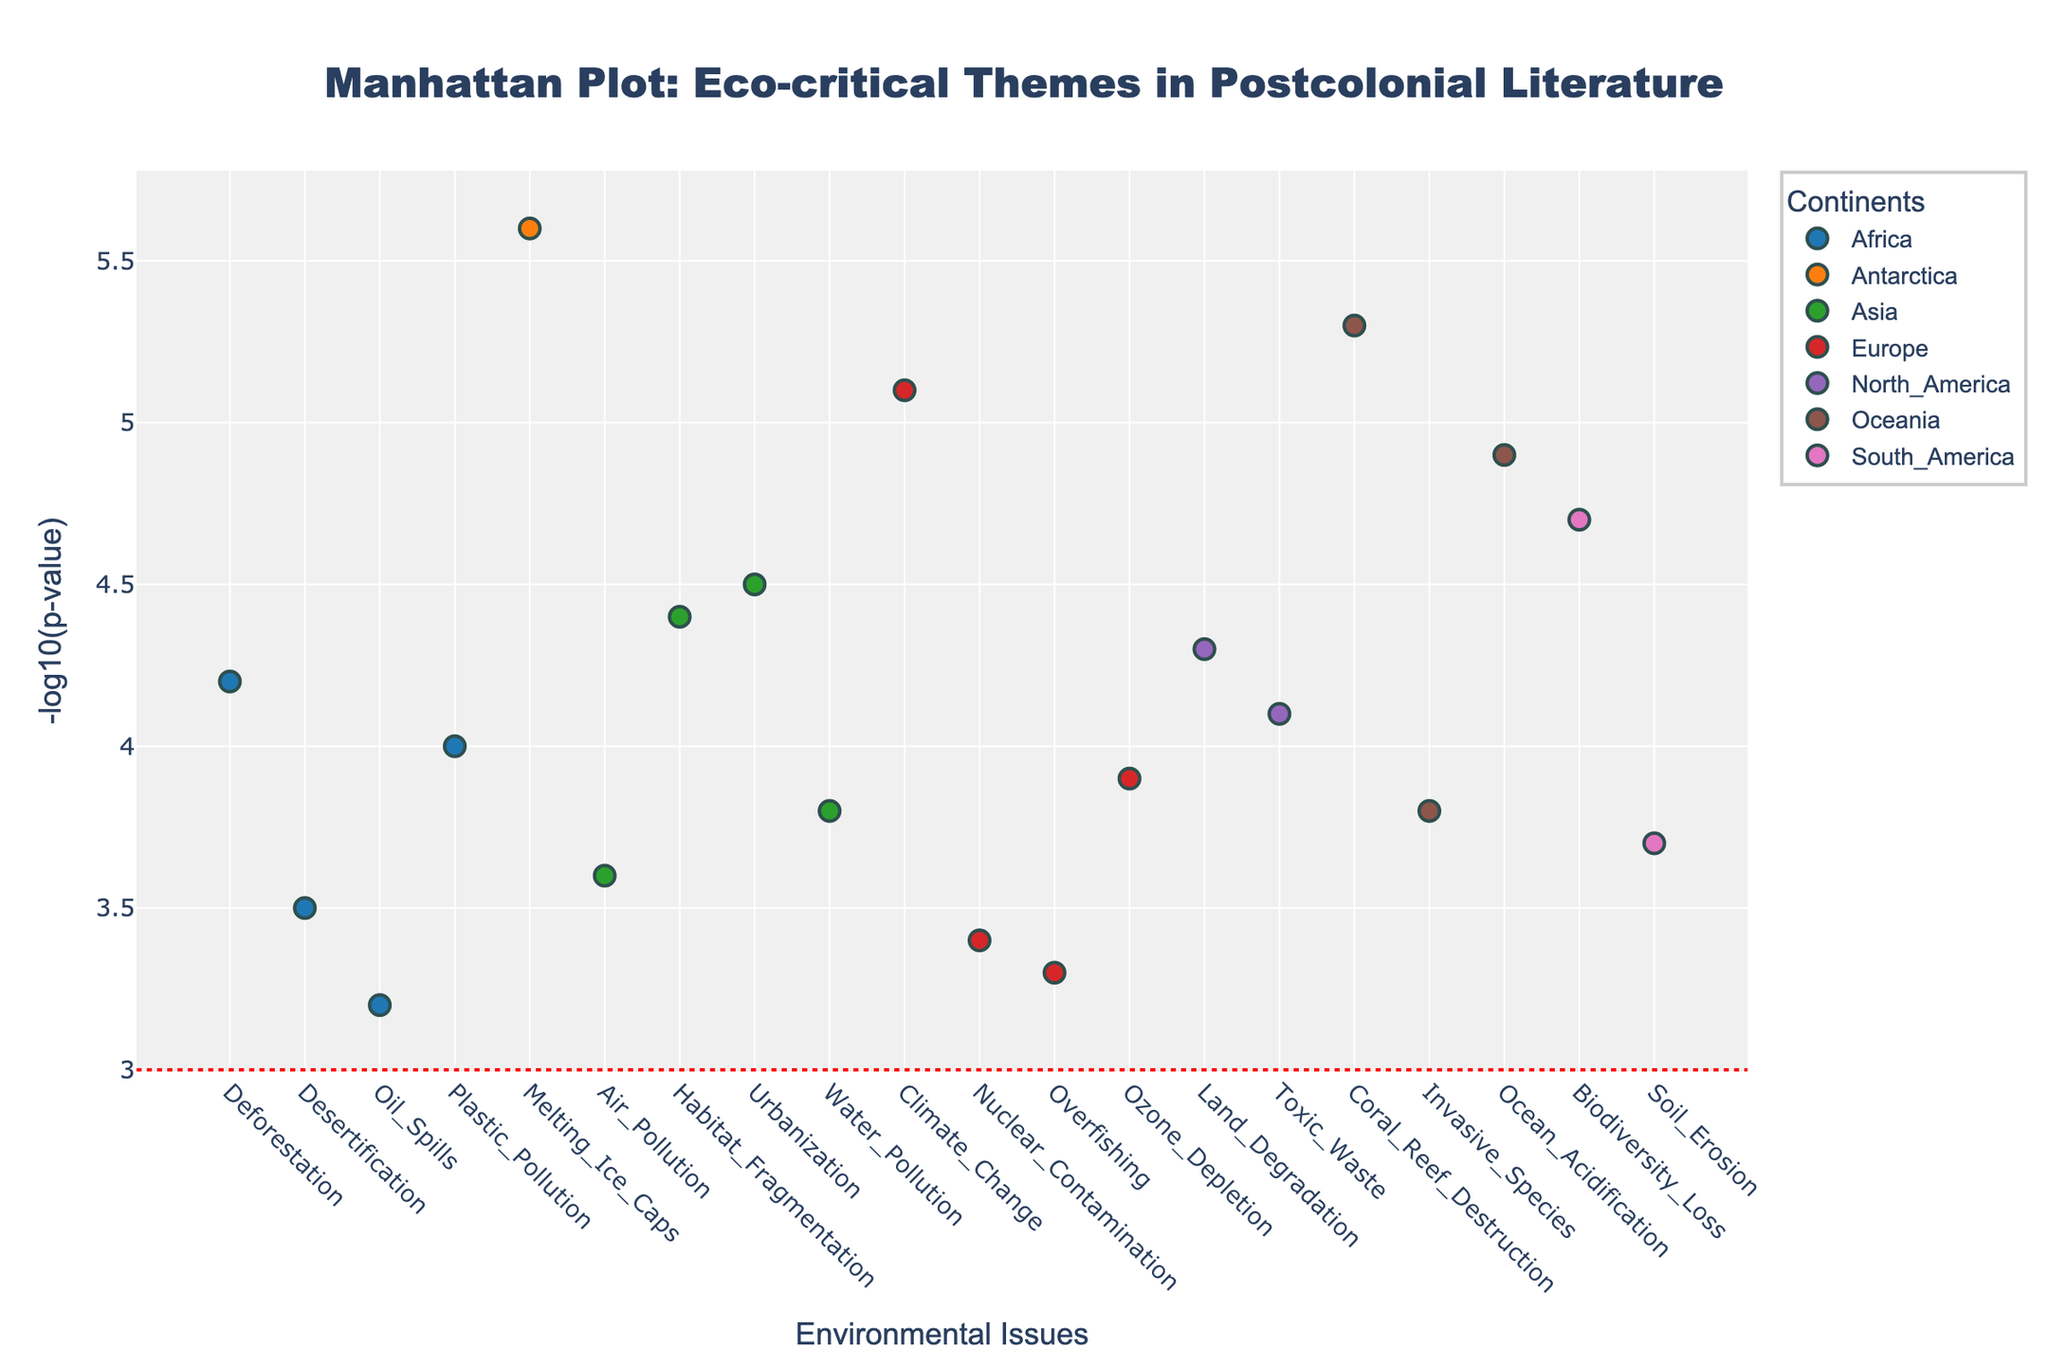What is the title of the plot? The title is located prominently at the top center of the plot. It reads, "Manhattan Plot: Eco-critical Themes in Postcolonial Literature".
Answer: Manhattan Plot: Eco-critical Themes in Postcolonial Literature Which continent has the environmental issue with the highest -log10(p-value)? By checking the y-axis values, the highest -log10(p-value) is 5.6 for the issue labeled "Melting_Ice_Caps" in "Antarctica".
Answer: Antarctica What does the horizontal red line at y=3 represent? A horizontal line drawn at y=3 signifies a threshold, often important in significance testing. A -log10(p-value) of 3 corresponds to a p-value of 0.001, indicating statistical significance.
Answer: A threshold of p-value = 0.001 How do Oceanic environmental issues compare in statistical significance? Oceanic issues plotted in Oceania can be evaluated by their y-axis values. "Coral_Reef_Destruction" stands at 5.3, and "Ocean_Acidification" stands at 4.9, indicating both issues are statistically significant and have high -log10(p-values).
Answer: Both are highly significant Which continent has the most environmental issues plotted in the figure? By counting the environmental issues per continent, "Asia" has the most with five issues listed: "Water_Pollution", "Air_Pollution", "Habitat_Fragmentation", "Urbanization", and "Plastic_Pollution".
Answer: Asia What is the median -log10(p-value) of the environmental issues in Europe? Sorting Europe’s values (3.3, 3.4, 3.9, 5.1) and finding the median, the two middle values are (3.9 and 3.4). Their average is (3.9+3.4)/2 = 3.65.
Answer: 3.65 Which environmental issue in North America has the higher -log10(p-value)? North America's issues are "Land_Degradation" at 4.3 and "Toxic_Waste" at 4.1. Comparing these values, "Land_Degradation" has a higher -log10(p-value).
Answer: Land_Degradation Is there any environmental issue in Africa with -log10(p-values) above 4.0? Reviewing African issues, "Deforestation" has 4.2, and "Plastic_Pollution" has 4.0. Therefore, "Deforestation" meets the criterion.
Answer: Deforestation How many environmental issues have a -log10(p-value) above 4.5? By checking each y-axis value, the issues are "Climate_Change", "Biodiversity_Loss", "Ocean_Acidification", "Coral_Reef_Destruction", "Melting_Ice_Caps", with y-values being: 5.1, 4.7, 4.9, 5.3, 5.6. Total count is 5.
Answer: 5 What appears to be the least significant environmental issue based on -log10(p-value)? The issue with the lowest -log10(p-value) on the y-axis is "Oil_Spills" in Africa with a value of 3.2.
Answer: Oil_Spills 